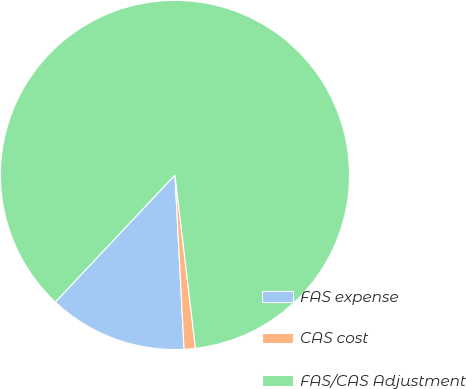Convert chart to OTSL. <chart><loc_0><loc_0><loc_500><loc_500><pie_chart><fcel>FAS expense<fcel>CAS cost<fcel>FAS/CAS Adjustment<nl><fcel>12.85%<fcel>1.04%<fcel>86.11%<nl></chart> 